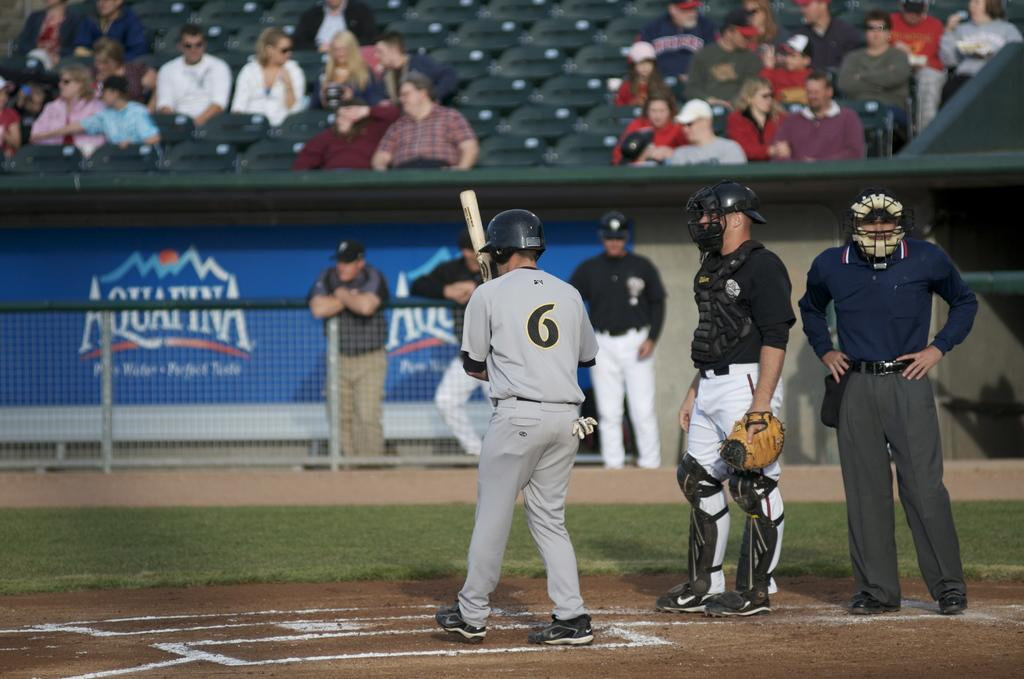<image>
Share a concise interpretation of the image provided. Bright blue Aquafina ads line the walls of a baseball stadium. 